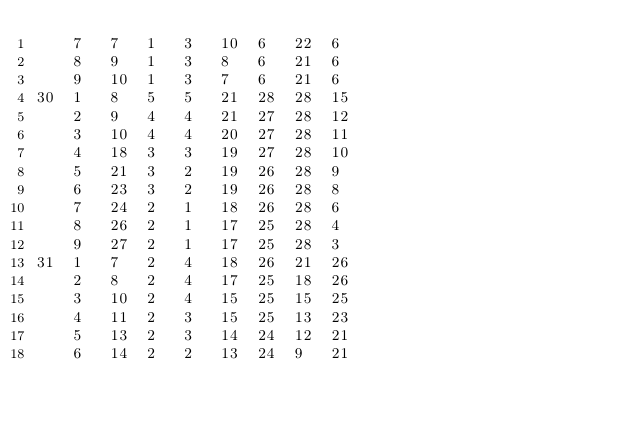Convert code to text. <code><loc_0><loc_0><loc_500><loc_500><_ObjectiveC_>	7	7	1	3	10	6	22	6	
	8	9	1	3	8	6	21	6	
	9	10	1	3	7	6	21	6	
30	1	8	5	5	21	28	28	15	
	2	9	4	4	21	27	28	12	
	3	10	4	4	20	27	28	11	
	4	18	3	3	19	27	28	10	
	5	21	3	2	19	26	28	9	
	6	23	3	2	19	26	28	8	
	7	24	2	1	18	26	28	6	
	8	26	2	1	17	25	28	4	
	9	27	2	1	17	25	28	3	
31	1	7	2	4	18	26	21	26	
	2	8	2	4	17	25	18	26	
	3	10	2	4	15	25	15	25	
	4	11	2	3	15	25	13	23	
	5	13	2	3	14	24	12	21	
	6	14	2	2	13	24	9	21	</code> 